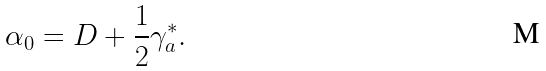<formula> <loc_0><loc_0><loc_500><loc_500>\alpha _ { 0 } = D + \frac { 1 } { 2 } \gamma _ { a } ^ { * } .</formula> 